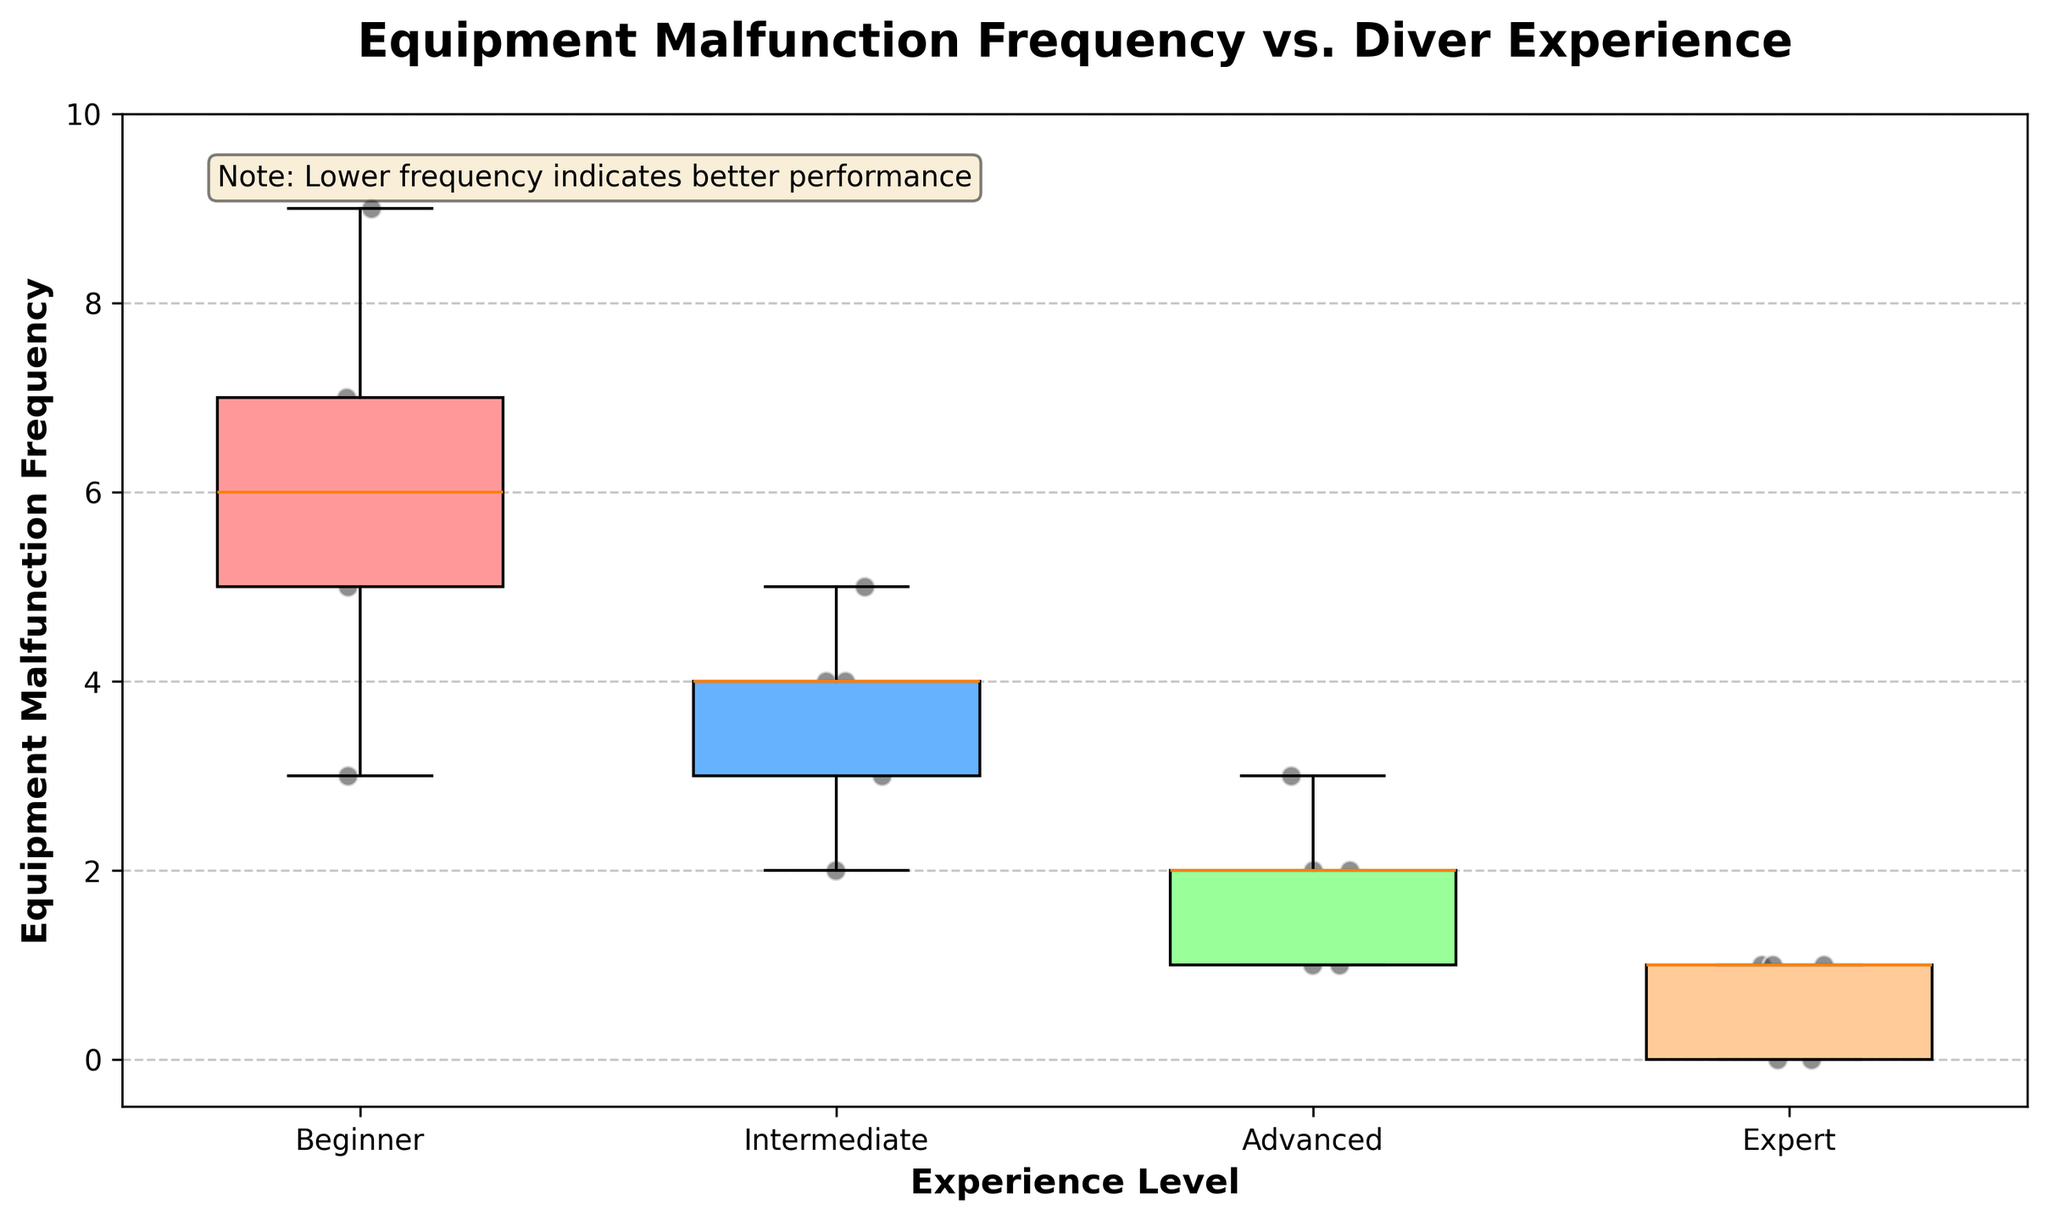what is the title of the plot? The title of the plot is located at the top of the figure and usually describes the content of the plot.
Answer: 'Equipment Malfunction Frequency vs. Diver Experience' what is the frequency range for the 'Beginner' experience level? The frequency range for 'Beginner' experience level can be established by examining the y-axis values covered by the box plot for 'Beginner'. The range is from the lowest data point to the highest data point.
Answer: 3 to 9 which experience level has the median closest to 2? To find this, locate the box plot that has its median line (the line inside the box) closest to 2. The 'Advanced' level median is at 2, followed closely by 'Intermediate' at 4.
Answer: Advanced how many data points are displayed for the 'Expert' level? Count the number of scatter points overlayed on the 'Expert' box plot. There are 5 points.
Answer: 5 which group shows the most variability in equipment malfunctions? The group with the widest box plot and longest whiskers shows the most variability. The 'Beginner' group has the widest range, indicating most variability.
Answer: Beginner which level has the fewest distinct values for equipment malfunction frequency? To determine this, look at the scatter points and the box plot spread. The 'Expert' level, with fewer scatter points close together, has fewer distinct values.
Answer: Expert what is the interquartile range (IQR) for the 'Beginner' experience level? The IQR is the difference between the third quartile (75th percentile) and the first quartile (25th percentile) of the box plot. For 'Beginner', Q3 is at 7 and Q1 is at 5, so the IQR is 7 - 5 = 2.
Answer: 2 compare the median equipment malfunction frequency between 'Intermediate' and 'Advanced'. which is higher? Identify the median lines within each box plot. The median for 'Intermediate' is higher at 4, compared to 'Advanced' at 2.
Answer: Intermediate which levels have data points at frequency 1? Observe the scatter points. Both 'Advanced' and 'Expert' have at least one data point at frequency 1.
Answer: Advanced, Expert 